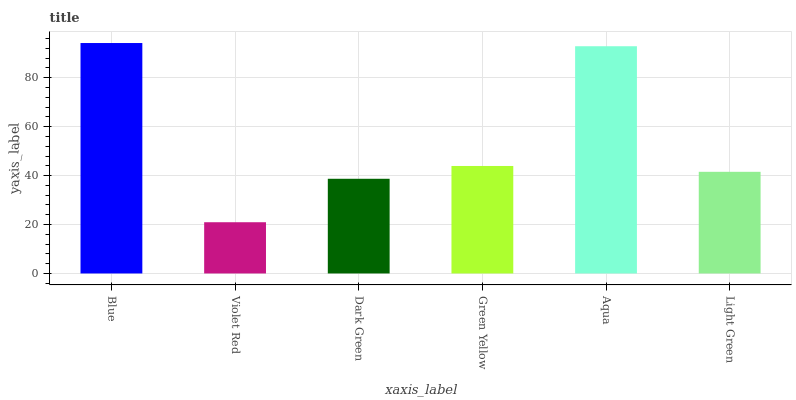Is Dark Green the minimum?
Answer yes or no. No. Is Dark Green the maximum?
Answer yes or no. No. Is Dark Green greater than Violet Red?
Answer yes or no. Yes. Is Violet Red less than Dark Green?
Answer yes or no. Yes. Is Violet Red greater than Dark Green?
Answer yes or no. No. Is Dark Green less than Violet Red?
Answer yes or no. No. Is Green Yellow the high median?
Answer yes or no. Yes. Is Light Green the low median?
Answer yes or no. Yes. Is Dark Green the high median?
Answer yes or no. No. Is Aqua the low median?
Answer yes or no. No. 